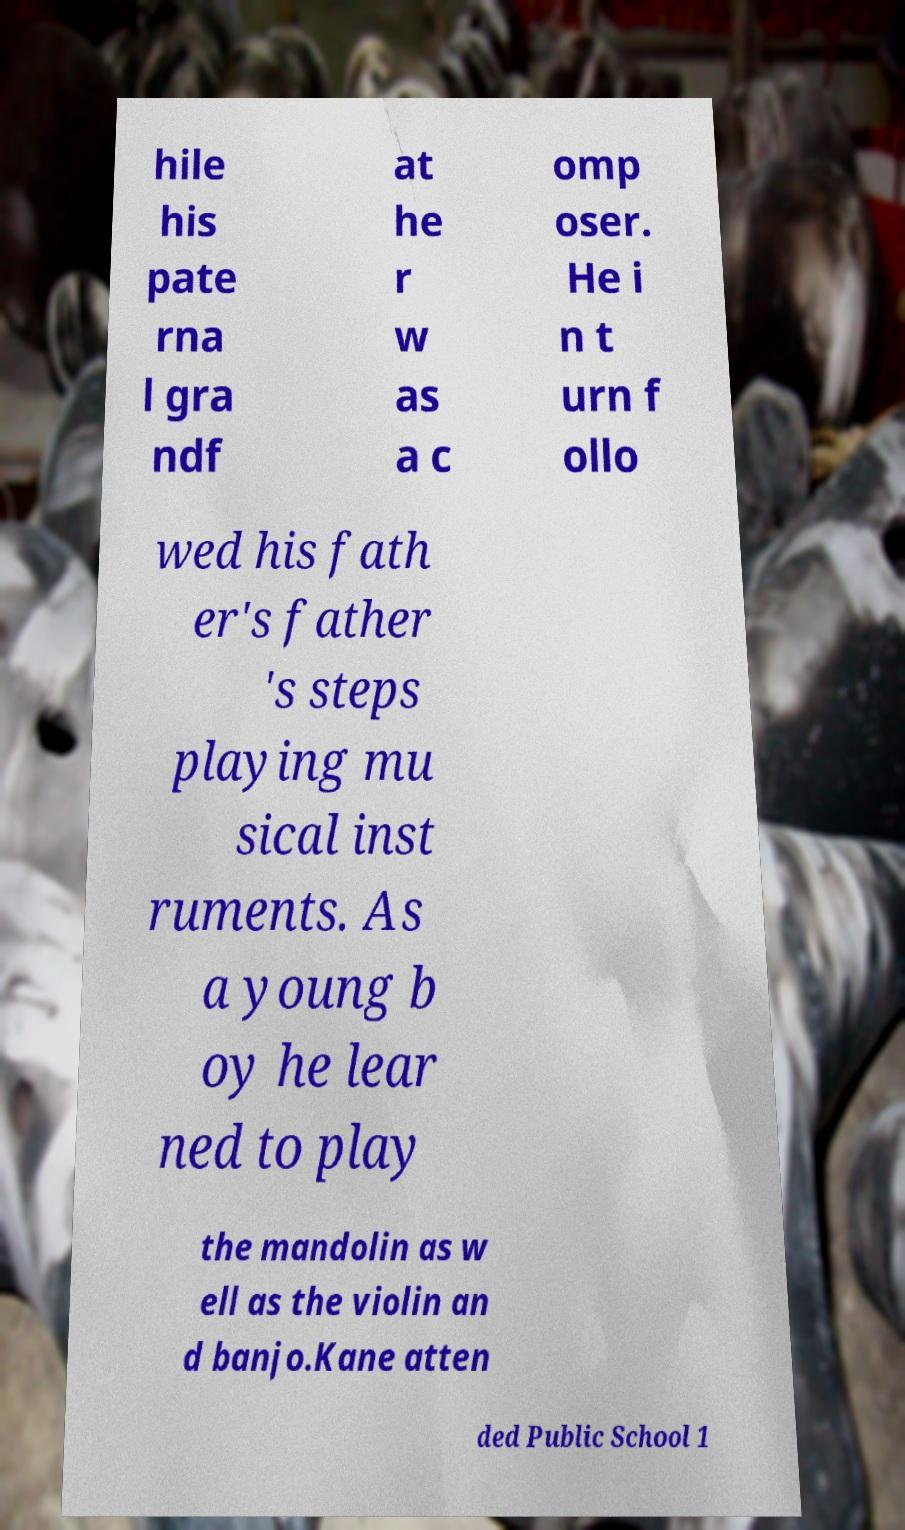Could you extract and type out the text from this image? hile his pate rna l gra ndf at he r w as a c omp oser. He i n t urn f ollo wed his fath er's father 's steps playing mu sical inst ruments. As a young b oy he lear ned to play the mandolin as w ell as the violin an d banjo.Kane atten ded Public School 1 